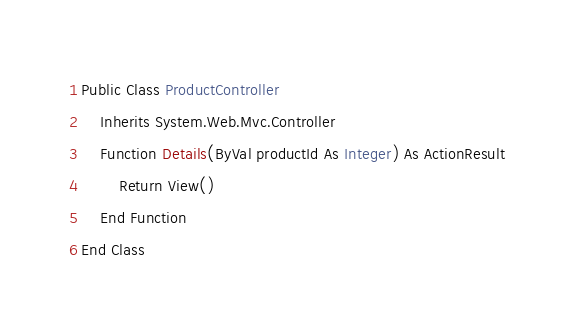Convert code to text. <code><loc_0><loc_0><loc_500><loc_500><_VisualBasic_>Public Class ProductController
    Inherits System.Web.Mvc.Controller
    Function Details(ByVal productId As Integer) As ActionResult
        Return View()
    End Function
End Class</code> 